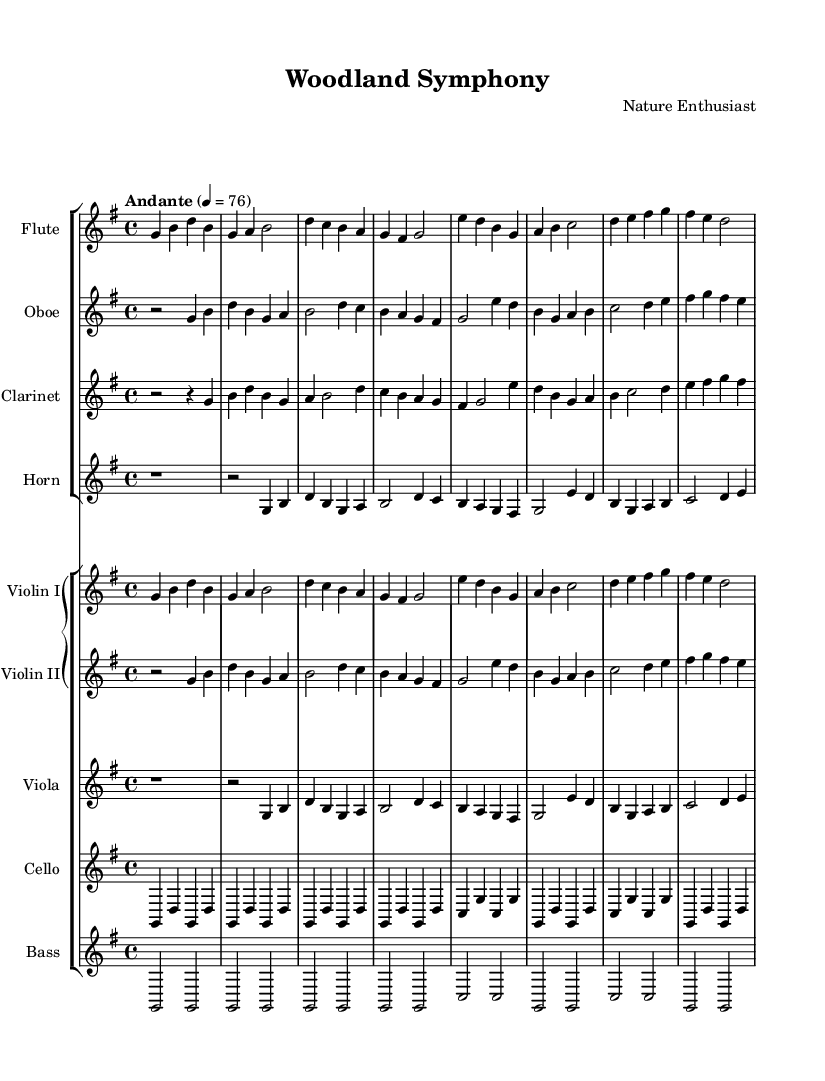What is the key signature of this music? The key signature indicates the note pitches that are altered throughout the piece. In this score, the presence of one sharp (F sharp) indicates that the key is G major.
Answer: G major What is the time signature of this music? The time signature shows how the beats are organized in each measure. Here, it is displayed as 4/4, which means there are four beats in each measure and each beat is a quarter note.
Answer: 4/4 What is the tempo marking of this piece? The tempo is given at the beginning of the score, indicating how fast the music should be played. The marking "Andante" specifies a moderate pace, and the number 76 indicates how many beats per minute it is set to.
Answer: Andante How many different instruments are included in this symphony? By examining the score, we can count seven distinct instruments: flute, oboe, clarinet, horn, violin I, violin II, viola, cello, and bass.
Answer: Seven What is the highest pitch instrument in this score? The flute is typically known for its high range among orchestral instruments, and reviewing the individual staves shows that it plays the highest pitches compared to others.
Answer: Flute Which section of the orchestra does the cello belong to? In the orchestration, cellos are part of the string section due to their stringed nature, which can be identified by their placement on the grand staff in the lower instruments section.
Answer: String section How many measures are in the flute part? To find the number of measures, we simply count the distinct musical sections or bars indicated by the vertical lines on the flute staff. There are eight measures shown.
Answer: Eight 